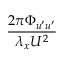<formula> <loc_0><loc_0><loc_500><loc_500>\frac { 2 \pi \Phi _ { u ^ { \prime } u ^ { \prime } } } { \lambda _ { x } U ^ { 2 } }</formula> 